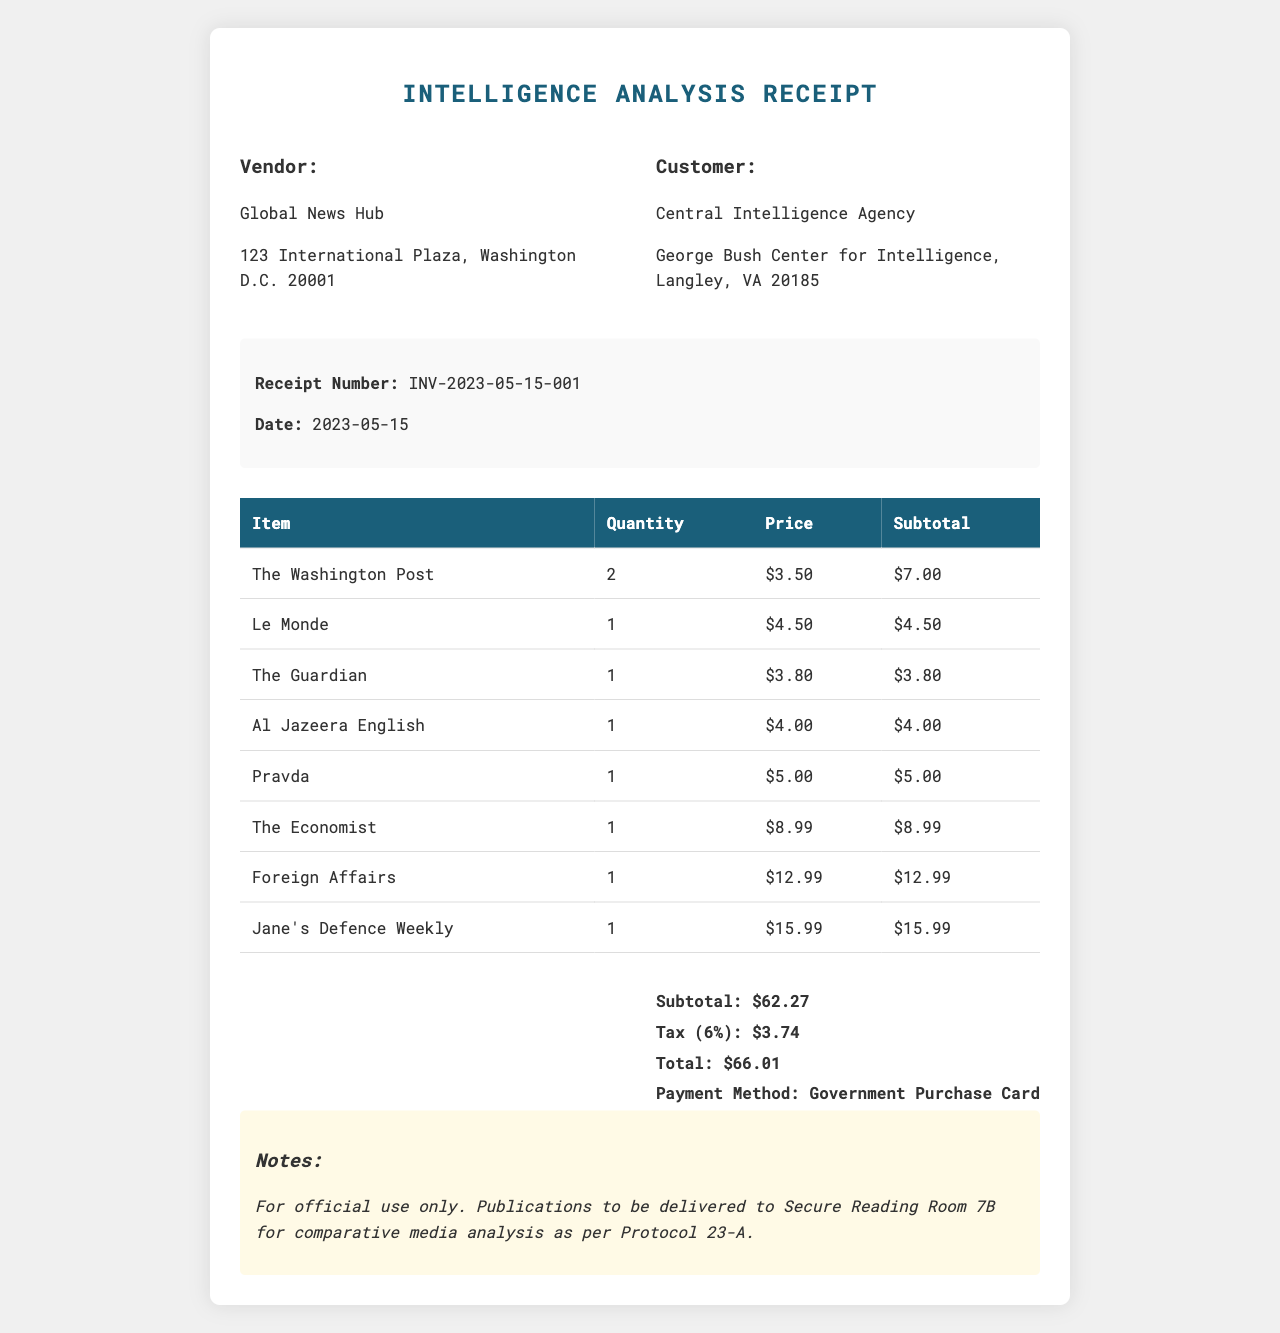What is the receipt number? The receipt number is a unique identifier for the transaction, shown at the top of the document.
Answer: INV-2023-05-15-001 What is the date of the transaction? The date indicates when the purchase was made, listed prominently on the receipt.
Answer: 2023-05-15 Who is the vendor for this transaction? The vendor name is the business from which the newspapers and magazines were purchased, found in the vendor section.
Answer: Global News Hub What item has the highest price? This refers to the item with the highest cost among those listed in the receipt's itemized table.
Answer: Jane's Defence Weekly What is the total amount spent? This is the final cost of the transaction, including tax, found at the bottom of the receipt.
Answer: $66.01 What was the payment method used? This refers to how the purchase was paid for, specified in the payment details.
Answer: Government Purchase Card How many copies of The Washington Post were purchased? This number indicates the quantity ordered of a specific publication, detailed in the item list.
Answer: 2 What is noted about the use of these publications? This note specifies the intended use of the purchased items, which is typically for a specific purpose or analysis.
Answer: For official use only What is the subtotal before tax? The subtotal represents the total cost of all items prior to any applicable taxes being added, found near the total section.
Answer: $62.27 